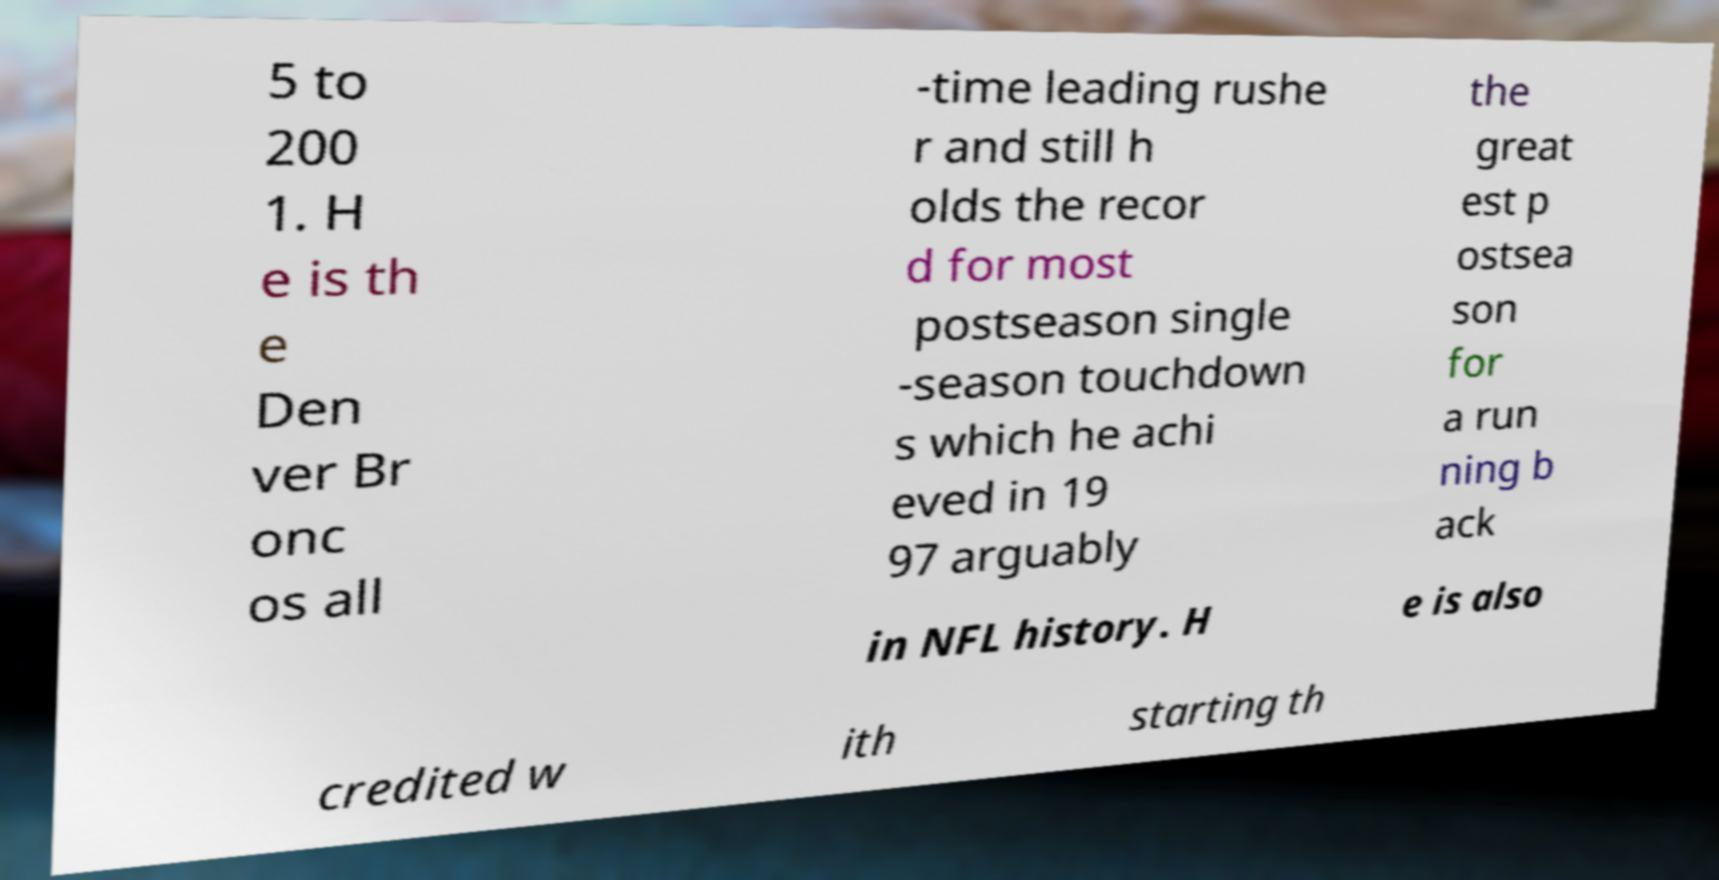For documentation purposes, I need the text within this image transcribed. Could you provide that? 5 to 200 1. H e is th e Den ver Br onc os all -time leading rushe r and still h olds the recor d for most postseason single -season touchdown s which he achi eved in 19 97 arguably the great est p ostsea son for a run ning b ack in NFL history. H e is also credited w ith starting th 